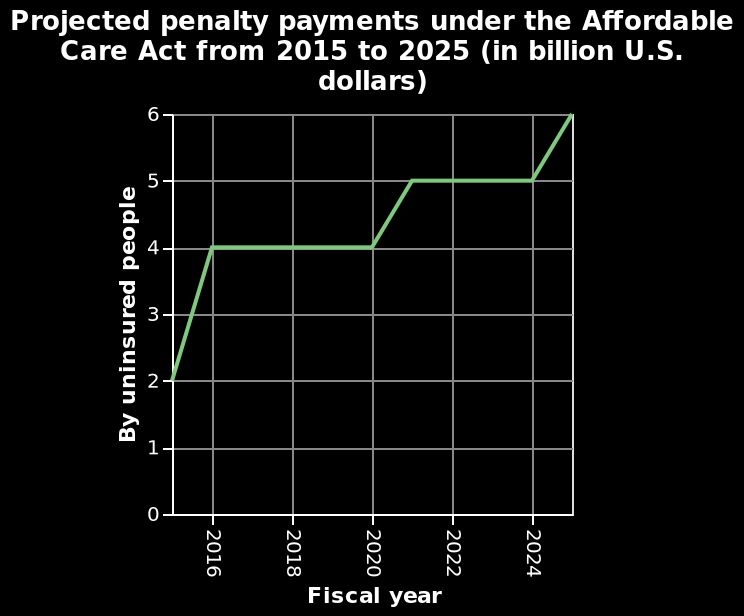<image>
During which period did the payments remain constant? The payments remained constant from 2016 to 2020. During which period did the payments increase? The payments increased from 2020 to 2022. What happened to the payments from 2020 to 2022? The payments increased (rose) during those years. 